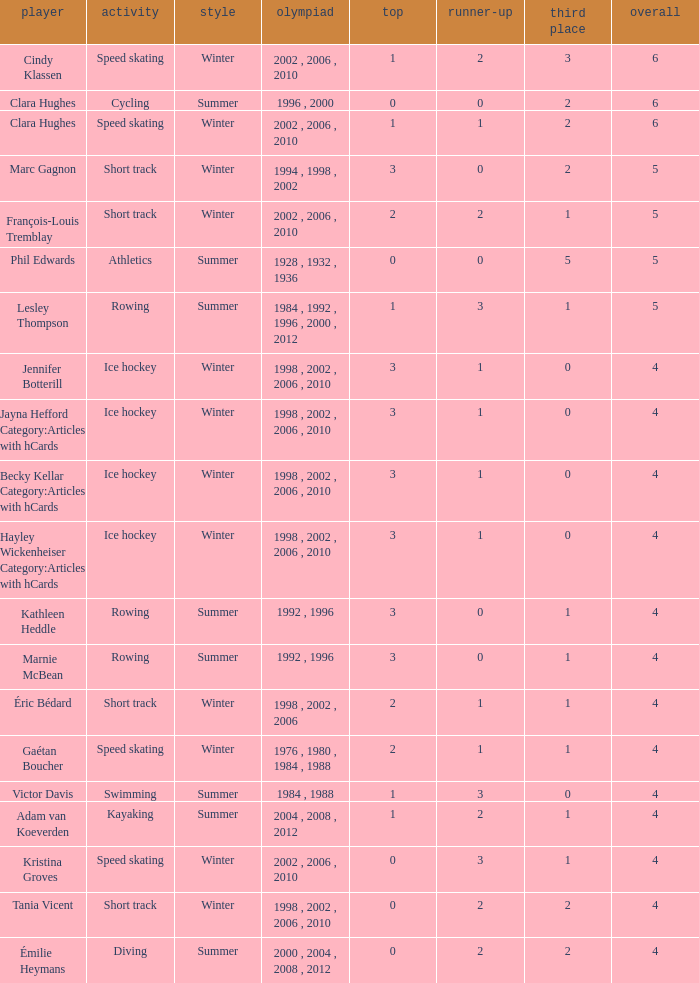What is the lowest number of bronze a short track athlete with 0 gold medals has? 2.0. 